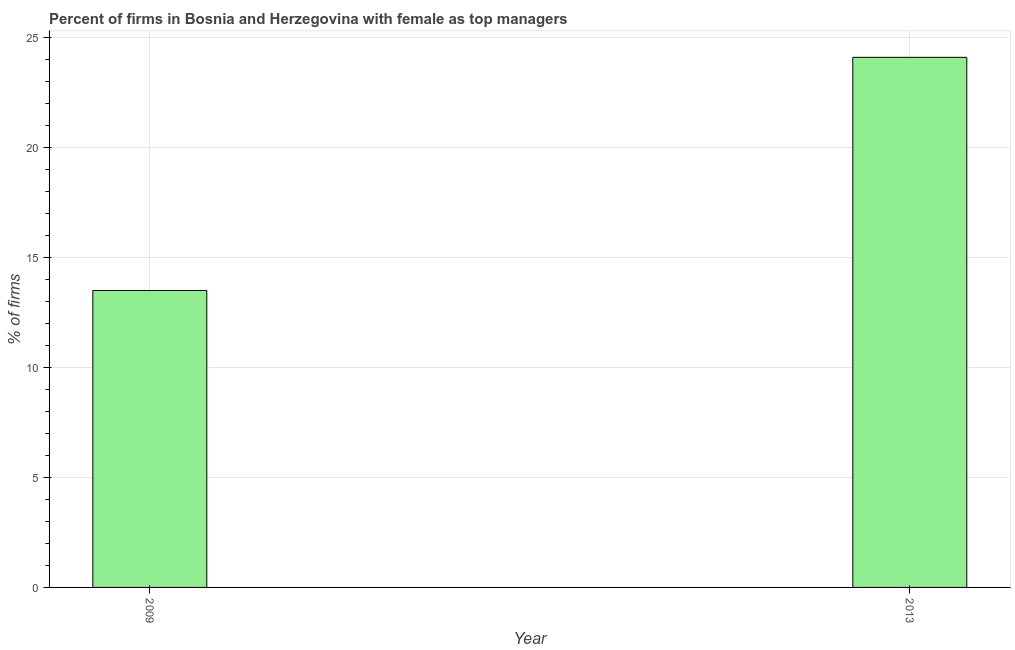What is the title of the graph?
Ensure brevity in your answer.  Percent of firms in Bosnia and Herzegovina with female as top managers. What is the label or title of the X-axis?
Keep it short and to the point. Year. What is the label or title of the Y-axis?
Provide a short and direct response. % of firms. What is the percentage of firms with female as top manager in 2009?
Make the answer very short. 13.5. Across all years, what is the maximum percentage of firms with female as top manager?
Keep it short and to the point. 24.1. In which year was the percentage of firms with female as top manager maximum?
Keep it short and to the point. 2013. What is the sum of the percentage of firms with female as top manager?
Your response must be concise. 37.6. What is the average percentage of firms with female as top manager per year?
Your answer should be compact. 18.8. What is the median percentage of firms with female as top manager?
Provide a short and direct response. 18.8. In how many years, is the percentage of firms with female as top manager greater than 20 %?
Your answer should be compact. 1. Do a majority of the years between 2009 and 2013 (inclusive) have percentage of firms with female as top manager greater than 8 %?
Your answer should be compact. Yes. What is the ratio of the percentage of firms with female as top manager in 2009 to that in 2013?
Make the answer very short. 0.56. What is the difference between two consecutive major ticks on the Y-axis?
Your response must be concise. 5. What is the % of firms of 2013?
Offer a terse response. 24.1. What is the difference between the % of firms in 2009 and 2013?
Ensure brevity in your answer.  -10.6. What is the ratio of the % of firms in 2009 to that in 2013?
Your answer should be compact. 0.56. 